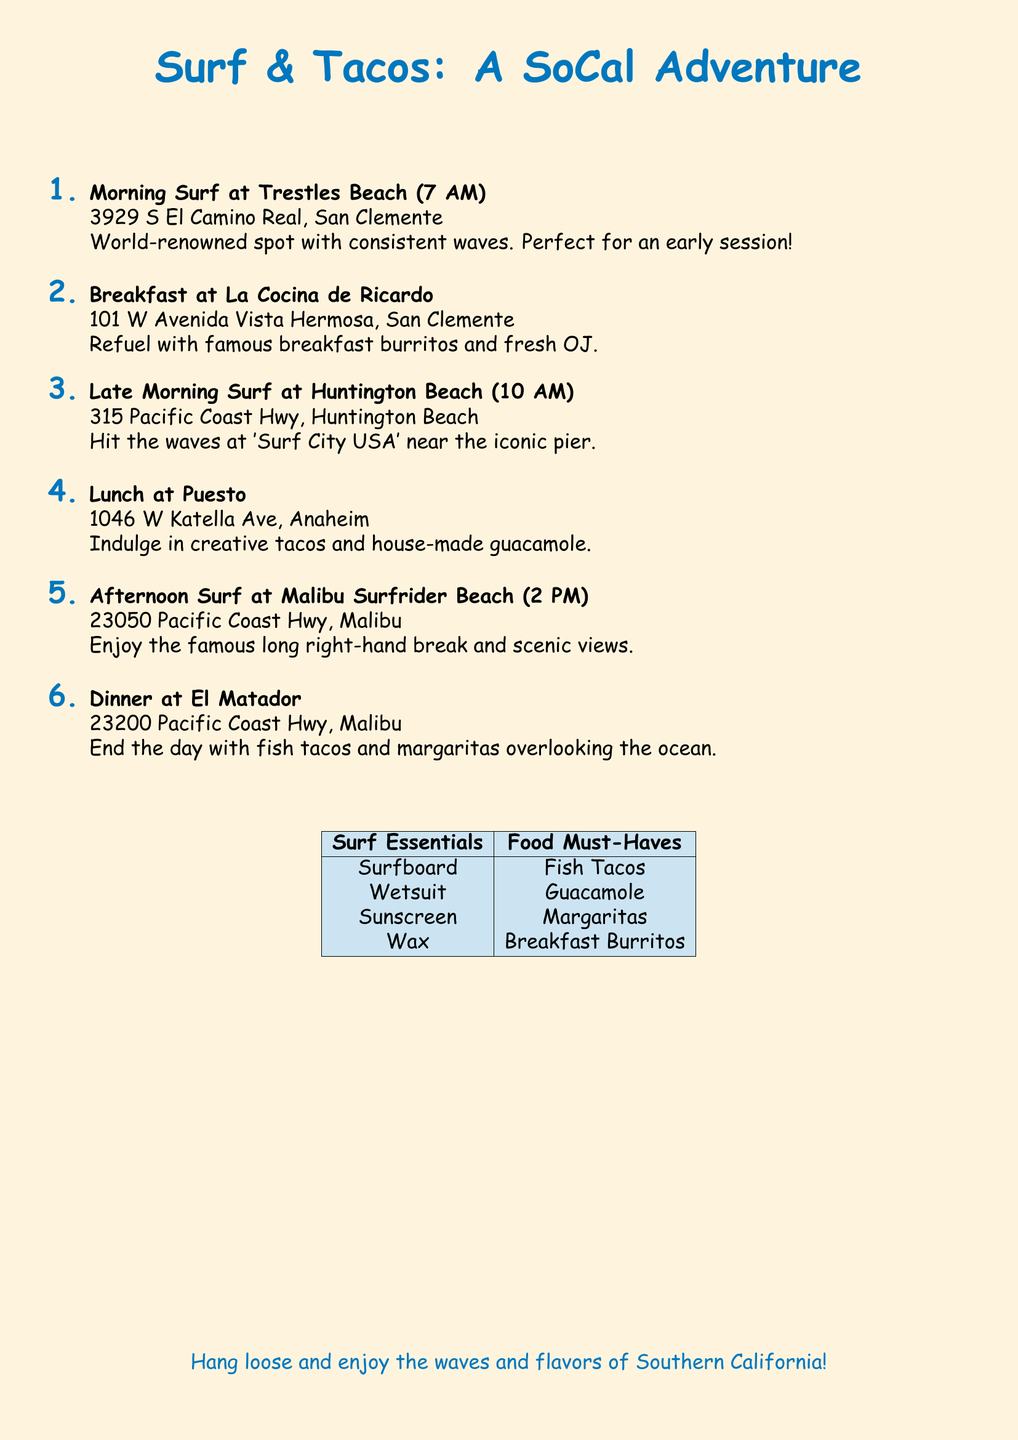What time does the morning surf start? The itinerary lists the morning surf at Trestles Beach starting at 7 AM.
Answer: 7 AM Where is La Cocina de Ricardo located? The document provides the address of La Cocina de Ricardo as 101 W Avenida Vista Hermosa, San Clemente.
Answer: 101 W Avenida Vista Hermosa, San Clemente What type of tacos can you enjoy at El Matador? The document specifies that you can enjoy fish tacos at El Matador.
Answer: Fish tacos How many surf spots are listed in the itinerary? The itinerary lists a total of three surf spots: Trestles Beach, Huntington Beach, and Malibu Surfrider Beach, which adds up to 3.
Answer: 3 What is the recommended drink at dinner? The itinerary suggests enjoying margaritas with dinner at El Matador.
Answer: Margaritas What meal can you have at Puesto? The itinerary mentions that Puesto offers creative tacos for lunch.
Answer: Creative tacos At what time is the afternoon surf at Malibu? The document indicates that the afternoon surf at Malibu Surfrider Beach occurs at 2 PM.
Answer: 2 PM What are the surf essentials listed? The document lists surf essentials such as surfboard, wetsuit, sunscreen, and wax.
Answer: Surfboard, wetsuit, sunscreen, wax What cuisine is the focus of this itinerary? The itinerary is centered around Mexican cuisine, specifically mentioning tacos and burritos.
Answer: Mexican cuisine 